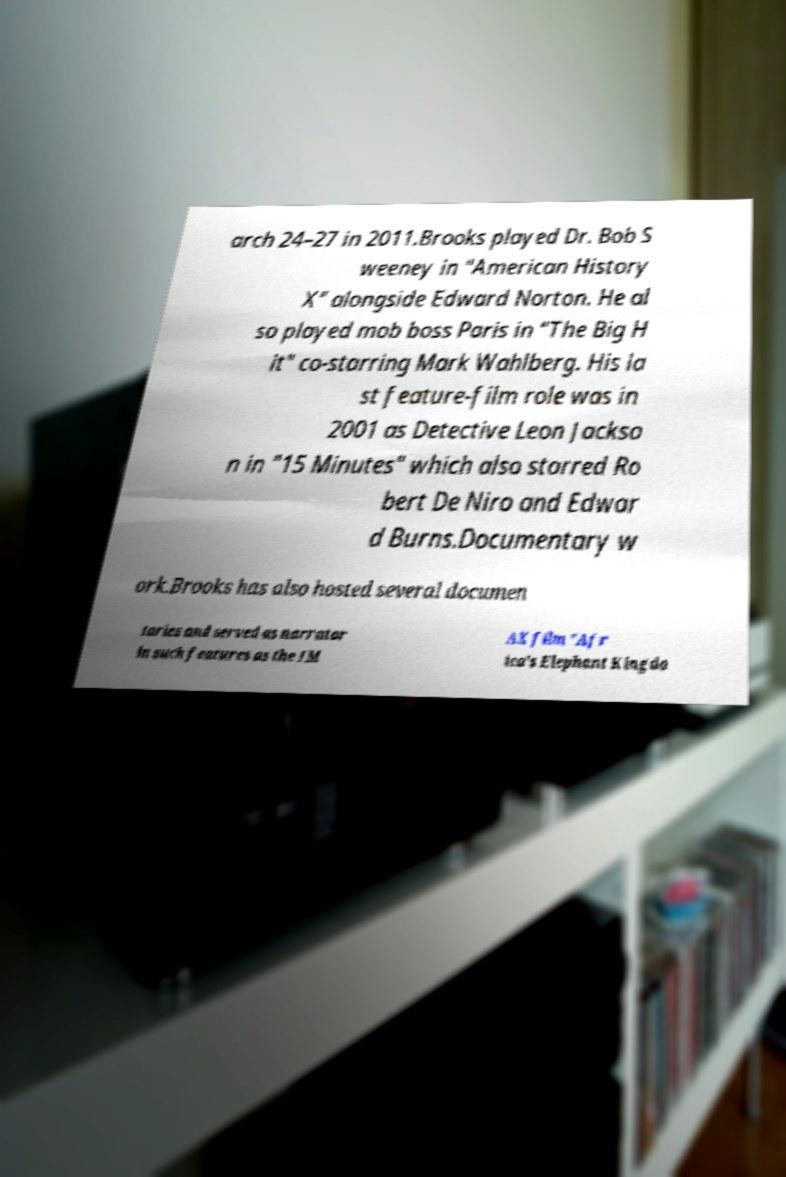Can you read and provide the text displayed in the image?This photo seems to have some interesting text. Can you extract and type it out for me? arch 24–27 in 2011.Brooks played Dr. Bob S weeney in "American History X" alongside Edward Norton. He al so played mob boss Paris in "The Big H it" co-starring Mark Wahlberg. His la st feature-film role was in 2001 as Detective Leon Jackso n in "15 Minutes" which also starred Ro bert De Niro and Edwar d Burns.Documentary w ork.Brooks has also hosted several documen taries and served as narrator in such features as the IM AX film "Afr ica's Elephant Kingdo 